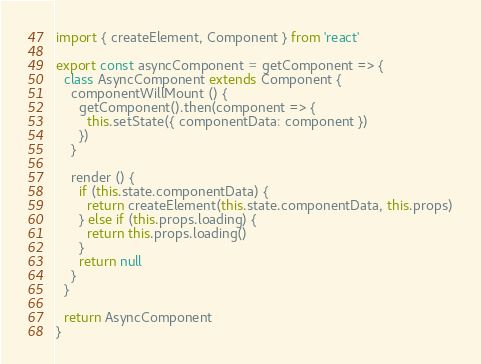<code> <loc_0><loc_0><loc_500><loc_500><_JavaScript_>import { createElement, Component } from 'react'

export const asyncComponent = getComponent => {
  class AsyncComponent extends Component {
    componentWillMount () {
      getComponent().then(component => {
        this.setState({ componentData: component })
      })
    }

    render () {
      if (this.state.componentData) {
        return createElement(this.state.componentData, this.props)
      } else if (this.props.loading) {
        return this.props.loading()
      }
      return null
    }
  }

  return AsyncComponent
}
</code> 